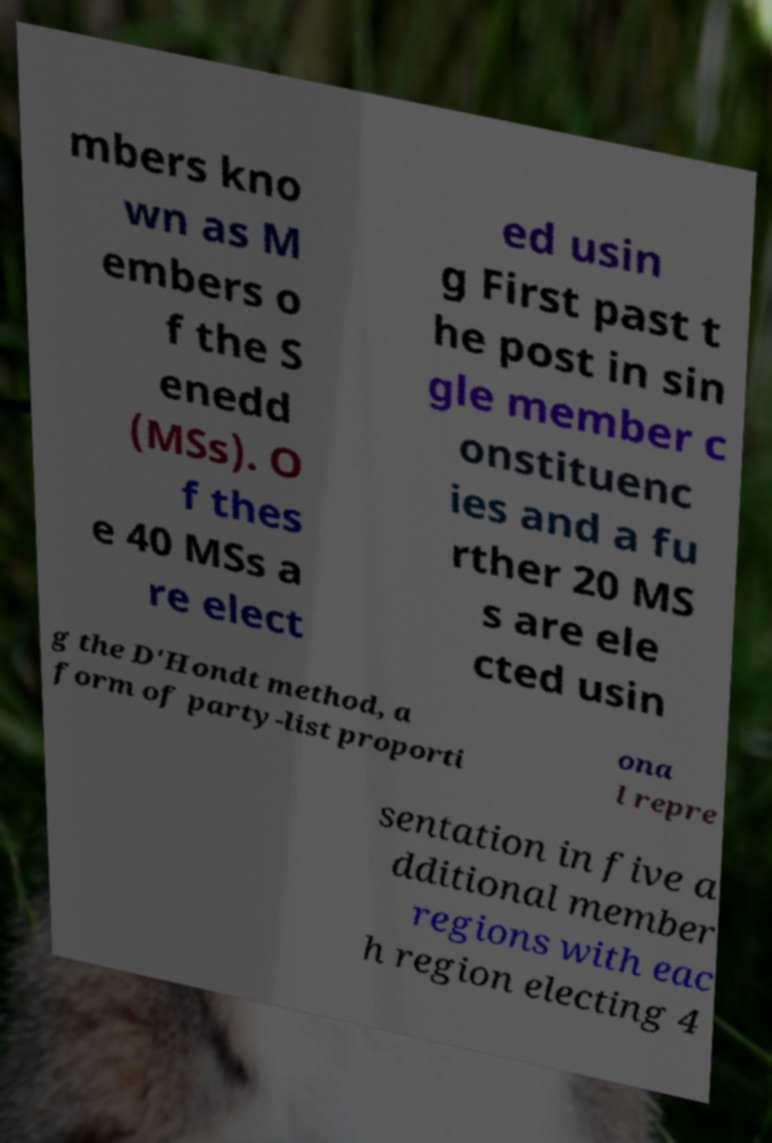Can you read and provide the text displayed in the image?This photo seems to have some interesting text. Can you extract and type it out for me? mbers kno wn as M embers o f the S enedd (MSs). O f thes e 40 MSs a re elect ed usin g First past t he post in sin gle member c onstituenc ies and a fu rther 20 MS s are ele cted usin g the D'Hondt method, a form of party-list proporti ona l repre sentation in five a dditional member regions with eac h region electing 4 